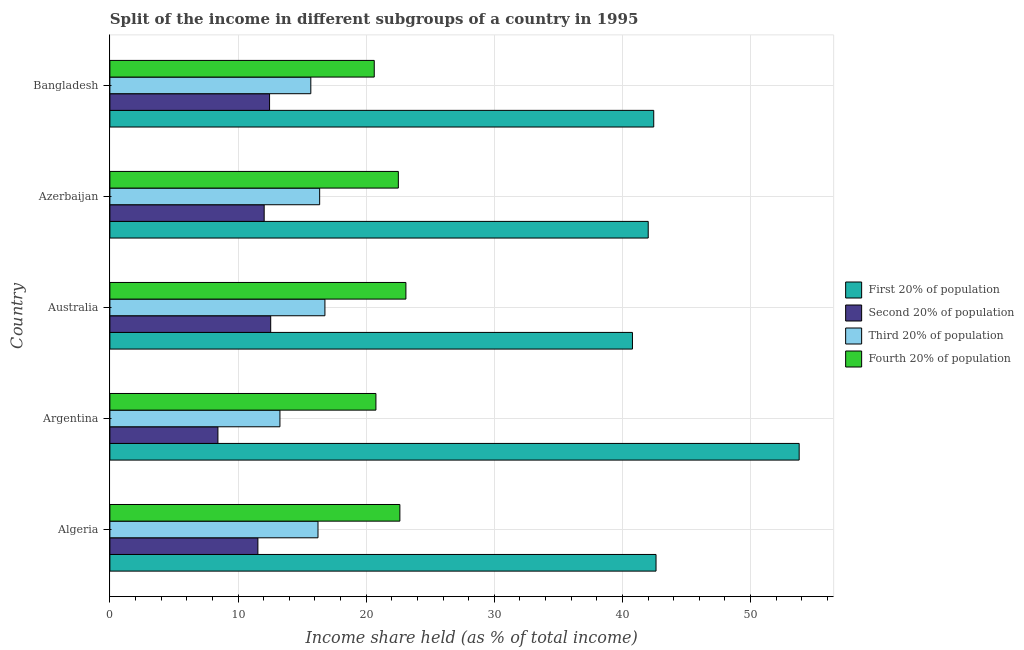Are the number of bars per tick equal to the number of legend labels?
Your answer should be very brief. Yes. How many bars are there on the 1st tick from the top?
Provide a short and direct response. 4. What is the label of the 1st group of bars from the top?
Offer a terse response. Bangladesh. In how many cases, is the number of bars for a given country not equal to the number of legend labels?
Keep it short and to the point. 0. What is the share of the income held by fourth 20% of the population in Algeria?
Offer a terse response. 22.63. Across all countries, what is the maximum share of the income held by second 20% of the population?
Your answer should be compact. 12.55. Across all countries, what is the minimum share of the income held by second 20% of the population?
Make the answer very short. 8.43. What is the total share of the income held by third 20% of the population in the graph?
Make the answer very short. 78.34. What is the difference between the share of the income held by first 20% of the population in Bangladesh and the share of the income held by second 20% of the population in Azerbaijan?
Offer a terse response. 30.4. What is the average share of the income held by third 20% of the population per country?
Provide a succinct answer. 15.67. What is the difference between the share of the income held by second 20% of the population and share of the income held by fourth 20% of the population in Australia?
Your answer should be compact. -10.55. In how many countries, is the share of the income held by third 20% of the population greater than 6 %?
Keep it short and to the point. 5. What is the difference between the highest and the second highest share of the income held by third 20% of the population?
Your answer should be compact. 0.41. What is the difference between the highest and the lowest share of the income held by second 20% of the population?
Give a very brief answer. 4.12. In how many countries, is the share of the income held by fourth 20% of the population greater than the average share of the income held by fourth 20% of the population taken over all countries?
Provide a short and direct response. 3. Is it the case that in every country, the sum of the share of the income held by second 20% of the population and share of the income held by first 20% of the population is greater than the sum of share of the income held by fourth 20% of the population and share of the income held by third 20% of the population?
Offer a terse response. Yes. What does the 3rd bar from the top in Australia represents?
Provide a succinct answer. Second 20% of population. What does the 2nd bar from the bottom in Bangladesh represents?
Offer a very short reply. Second 20% of population. Is it the case that in every country, the sum of the share of the income held by first 20% of the population and share of the income held by second 20% of the population is greater than the share of the income held by third 20% of the population?
Your response must be concise. Yes. How many countries are there in the graph?
Provide a short and direct response. 5. Does the graph contain any zero values?
Provide a short and direct response. No. How are the legend labels stacked?
Provide a succinct answer. Vertical. What is the title of the graph?
Offer a very short reply. Split of the income in different subgroups of a country in 1995. Does "Agriculture" appear as one of the legend labels in the graph?
Your response must be concise. No. What is the label or title of the X-axis?
Make the answer very short. Income share held (as % of total income). What is the label or title of the Y-axis?
Provide a succinct answer. Country. What is the Income share held (as % of total income) in First 20% of population in Algeria?
Keep it short and to the point. 42.62. What is the Income share held (as % of total income) in Second 20% of population in Algeria?
Offer a terse response. 11.55. What is the Income share held (as % of total income) in Third 20% of population in Algeria?
Your answer should be compact. 16.24. What is the Income share held (as % of total income) of Fourth 20% of population in Algeria?
Provide a succinct answer. 22.63. What is the Income share held (as % of total income) of First 20% of population in Argentina?
Provide a short and direct response. 53.79. What is the Income share held (as % of total income) of Second 20% of population in Argentina?
Make the answer very short. 8.43. What is the Income share held (as % of total income) of Third 20% of population in Argentina?
Your response must be concise. 13.27. What is the Income share held (as % of total income) of Fourth 20% of population in Argentina?
Keep it short and to the point. 20.76. What is the Income share held (as % of total income) in First 20% of population in Australia?
Your response must be concise. 40.78. What is the Income share held (as % of total income) in Second 20% of population in Australia?
Your answer should be very brief. 12.55. What is the Income share held (as % of total income) in Third 20% of population in Australia?
Offer a very short reply. 16.78. What is the Income share held (as % of total income) in Fourth 20% of population in Australia?
Your answer should be compact. 23.1. What is the Income share held (as % of total income) of First 20% of population in Azerbaijan?
Offer a terse response. 42.01. What is the Income share held (as % of total income) of Second 20% of population in Azerbaijan?
Your answer should be compact. 12.04. What is the Income share held (as % of total income) of Third 20% of population in Azerbaijan?
Your response must be concise. 16.37. What is the Income share held (as % of total income) of Fourth 20% of population in Azerbaijan?
Your answer should be compact. 22.51. What is the Income share held (as % of total income) of First 20% of population in Bangladesh?
Your answer should be compact. 42.44. What is the Income share held (as % of total income) in Second 20% of population in Bangladesh?
Ensure brevity in your answer.  12.46. What is the Income share held (as % of total income) of Third 20% of population in Bangladesh?
Ensure brevity in your answer.  15.68. What is the Income share held (as % of total income) in Fourth 20% of population in Bangladesh?
Offer a terse response. 20.63. Across all countries, what is the maximum Income share held (as % of total income) in First 20% of population?
Your answer should be very brief. 53.79. Across all countries, what is the maximum Income share held (as % of total income) in Second 20% of population?
Keep it short and to the point. 12.55. Across all countries, what is the maximum Income share held (as % of total income) in Third 20% of population?
Your response must be concise. 16.78. Across all countries, what is the maximum Income share held (as % of total income) in Fourth 20% of population?
Make the answer very short. 23.1. Across all countries, what is the minimum Income share held (as % of total income) of First 20% of population?
Provide a short and direct response. 40.78. Across all countries, what is the minimum Income share held (as % of total income) in Second 20% of population?
Your response must be concise. 8.43. Across all countries, what is the minimum Income share held (as % of total income) of Third 20% of population?
Offer a terse response. 13.27. Across all countries, what is the minimum Income share held (as % of total income) in Fourth 20% of population?
Offer a terse response. 20.63. What is the total Income share held (as % of total income) in First 20% of population in the graph?
Your answer should be compact. 221.64. What is the total Income share held (as % of total income) in Second 20% of population in the graph?
Provide a short and direct response. 57.03. What is the total Income share held (as % of total income) of Third 20% of population in the graph?
Ensure brevity in your answer.  78.34. What is the total Income share held (as % of total income) in Fourth 20% of population in the graph?
Offer a terse response. 109.63. What is the difference between the Income share held (as % of total income) of First 20% of population in Algeria and that in Argentina?
Your response must be concise. -11.17. What is the difference between the Income share held (as % of total income) of Second 20% of population in Algeria and that in Argentina?
Offer a terse response. 3.12. What is the difference between the Income share held (as % of total income) of Third 20% of population in Algeria and that in Argentina?
Give a very brief answer. 2.97. What is the difference between the Income share held (as % of total income) in Fourth 20% of population in Algeria and that in Argentina?
Provide a short and direct response. 1.87. What is the difference between the Income share held (as % of total income) in First 20% of population in Algeria and that in Australia?
Ensure brevity in your answer.  1.84. What is the difference between the Income share held (as % of total income) in Third 20% of population in Algeria and that in Australia?
Offer a very short reply. -0.54. What is the difference between the Income share held (as % of total income) of Fourth 20% of population in Algeria and that in Australia?
Provide a succinct answer. -0.47. What is the difference between the Income share held (as % of total income) of First 20% of population in Algeria and that in Azerbaijan?
Offer a very short reply. 0.61. What is the difference between the Income share held (as % of total income) in Second 20% of population in Algeria and that in Azerbaijan?
Provide a succinct answer. -0.49. What is the difference between the Income share held (as % of total income) of Third 20% of population in Algeria and that in Azerbaijan?
Give a very brief answer. -0.13. What is the difference between the Income share held (as % of total income) in Fourth 20% of population in Algeria and that in Azerbaijan?
Your answer should be very brief. 0.12. What is the difference between the Income share held (as % of total income) of First 20% of population in Algeria and that in Bangladesh?
Your answer should be very brief. 0.18. What is the difference between the Income share held (as % of total income) of Second 20% of population in Algeria and that in Bangladesh?
Your answer should be very brief. -0.91. What is the difference between the Income share held (as % of total income) of Third 20% of population in Algeria and that in Bangladesh?
Offer a terse response. 0.56. What is the difference between the Income share held (as % of total income) of Fourth 20% of population in Algeria and that in Bangladesh?
Ensure brevity in your answer.  2. What is the difference between the Income share held (as % of total income) in First 20% of population in Argentina and that in Australia?
Give a very brief answer. 13.01. What is the difference between the Income share held (as % of total income) in Second 20% of population in Argentina and that in Australia?
Offer a terse response. -4.12. What is the difference between the Income share held (as % of total income) in Third 20% of population in Argentina and that in Australia?
Your answer should be very brief. -3.51. What is the difference between the Income share held (as % of total income) of Fourth 20% of population in Argentina and that in Australia?
Offer a terse response. -2.34. What is the difference between the Income share held (as % of total income) of First 20% of population in Argentina and that in Azerbaijan?
Offer a terse response. 11.78. What is the difference between the Income share held (as % of total income) in Second 20% of population in Argentina and that in Azerbaijan?
Your answer should be compact. -3.61. What is the difference between the Income share held (as % of total income) in Third 20% of population in Argentina and that in Azerbaijan?
Ensure brevity in your answer.  -3.1. What is the difference between the Income share held (as % of total income) of Fourth 20% of population in Argentina and that in Azerbaijan?
Offer a very short reply. -1.75. What is the difference between the Income share held (as % of total income) of First 20% of population in Argentina and that in Bangladesh?
Make the answer very short. 11.35. What is the difference between the Income share held (as % of total income) of Second 20% of population in Argentina and that in Bangladesh?
Your answer should be very brief. -4.03. What is the difference between the Income share held (as % of total income) in Third 20% of population in Argentina and that in Bangladesh?
Provide a succinct answer. -2.41. What is the difference between the Income share held (as % of total income) of Fourth 20% of population in Argentina and that in Bangladesh?
Ensure brevity in your answer.  0.13. What is the difference between the Income share held (as % of total income) of First 20% of population in Australia and that in Azerbaijan?
Your response must be concise. -1.23. What is the difference between the Income share held (as % of total income) of Second 20% of population in Australia and that in Azerbaijan?
Offer a very short reply. 0.51. What is the difference between the Income share held (as % of total income) of Third 20% of population in Australia and that in Azerbaijan?
Your answer should be compact. 0.41. What is the difference between the Income share held (as % of total income) in Fourth 20% of population in Australia and that in Azerbaijan?
Provide a succinct answer. 0.59. What is the difference between the Income share held (as % of total income) of First 20% of population in Australia and that in Bangladesh?
Your response must be concise. -1.66. What is the difference between the Income share held (as % of total income) of Second 20% of population in Australia and that in Bangladesh?
Provide a succinct answer. 0.09. What is the difference between the Income share held (as % of total income) in Fourth 20% of population in Australia and that in Bangladesh?
Offer a terse response. 2.47. What is the difference between the Income share held (as % of total income) in First 20% of population in Azerbaijan and that in Bangladesh?
Give a very brief answer. -0.43. What is the difference between the Income share held (as % of total income) of Second 20% of population in Azerbaijan and that in Bangladesh?
Offer a very short reply. -0.42. What is the difference between the Income share held (as % of total income) of Third 20% of population in Azerbaijan and that in Bangladesh?
Make the answer very short. 0.69. What is the difference between the Income share held (as % of total income) of Fourth 20% of population in Azerbaijan and that in Bangladesh?
Ensure brevity in your answer.  1.88. What is the difference between the Income share held (as % of total income) in First 20% of population in Algeria and the Income share held (as % of total income) in Second 20% of population in Argentina?
Provide a short and direct response. 34.19. What is the difference between the Income share held (as % of total income) of First 20% of population in Algeria and the Income share held (as % of total income) of Third 20% of population in Argentina?
Keep it short and to the point. 29.35. What is the difference between the Income share held (as % of total income) in First 20% of population in Algeria and the Income share held (as % of total income) in Fourth 20% of population in Argentina?
Your response must be concise. 21.86. What is the difference between the Income share held (as % of total income) of Second 20% of population in Algeria and the Income share held (as % of total income) of Third 20% of population in Argentina?
Your answer should be very brief. -1.72. What is the difference between the Income share held (as % of total income) of Second 20% of population in Algeria and the Income share held (as % of total income) of Fourth 20% of population in Argentina?
Ensure brevity in your answer.  -9.21. What is the difference between the Income share held (as % of total income) of Third 20% of population in Algeria and the Income share held (as % of total income) of Fourth 20% of population in Argentina?
Your response must be concise. -4.52. What is the difference between the Income share held (as % of total income) in First 20% of population in Algeria and the Income share held (as % of total income) in Second 20% of population in Australia?
Provide a short and direct response. 30.07. What is the difference between the Income share held (as % of total income) in First 20% of population in Algeria and the Income share held (as % of total income) in Third 20% of population in Australia?
Your response must be concise. 25.84. What is the difference between the Income share held (as % of total income) of First 20% of population in Algeria and the Income share held (as % of total income) of Fourth 20% of population in Australia?
Give a very brief answer. 19.52. What is the difference between the Income share held (as % of total income) of Second 20% of population in Algeria and the Income share held (as % of total income) of Third 20% of population in Australia?
Ensure brevity in your answer.  -5.23. What is the difference between the Income share held (as % of total income) of Second 20% of population in Algeria and the Income share held (as % of total income) of Fourth 20% of population in Australia?
Give a very brief answer. -11.55. What is the difference between the Income share held (as % of total income) in Third 20% of population in Algeria and the Income share held (as % of total income) in Fourth 20% of population in Australia?
Provide a short and direct response. -6.86. What is the difference between the Income share held (as % of total income) in First 20% of population in Algeria and the Income share held (as % of total income) in Second 20% of population in Azerbaijan?
Give a very brief answer. 30.58. What is the difference between the Income share held (as % of total income) of First 20% of population in Algeria and the Income share held (as % of total income) of Third 20% of population in Azerbaijan?
Ensure brevity in your answer.  26.25. What is the difference between the Income share held (as % of total income) of First 20% of population in Algeria and the Income share held (as % of total income) of Fourth 20% of population in Azerbaijan?
Your answer should be very brief. 20.11. What is the difference between the Income share held (as % of total income) of Second 20% of population in Algeria and the Income share held (as % of total income) of Third 20% of population in Azerbaijan?
Offer a very short reply. -4.82. What is the difference between the Income share held (as % of total income) of Second 20% of population in Algeria and the Income share held (as % of total income) of Fourth 20% of population in Azerbaijan?
Keep it short and to the point. -10.96. What is the difference between the Income share held (as % of total income) of Third 20% of population in Algeria and the Income share held (as % of total income) of Fourth 20% of population in Azerbaijan?
Ensure brevity in your answer.  -6.27. What is the difference between the Income share held (as % of total income) of First 20% of population in Algeria and the Income share held (as % of total income) of Second 20% of population in Bangladesh?
Your response must be concise. 30.16. What is the difference between the Income share held (as % of total income) in First 20% of population in Algeria and the Income share held (as % of total income) in Third 20% of population in Bangladesh?
Give a very brief answer. 26.94. What is the difference between the Income share held (as % of total income) of First 20% of population in Algeria and the Income share held (as % of total income) of Fourth 20% of population in Bangladesh?
Give a very brief answer. 21.99. What is the difference between the Income share held (as % of total income) in Second 20% of population in Algeria and the Income share held (as % of total income) in Third 20% of population in Bangladesh?
Your response must be concise. -4.13. What is the difference between the Income share held (as % of total income) of Second 20% of population in Algeria and the Income share held (as % of total income) of Fourth 20% of population in Bangladesh?
Your response must be concise. -9.08. What is the difference between the Income share held (as % of total income) in Third 20% of population in Algeria and the Income share held (as % of total income) in Fourth 20% of population in Bangladesh?
Offer a terse response. -4.39. What is the difference between the Income share held (as % of total income) in First 20% of population in Argentina and the Income share held (as % of total income) in Second 20% of population in Australia?
Your response must be concise. 41.24. What is the difference between the Income share held (as % of total income) of First 20% of population in Argentina and the Income share held (as % of total income) of Third 20% of population in Australia?
Offer a very short reply. 37.01. What is the difference between the Income share held (as % of total income) in First 20% of population in Argentina and the Income share held (as % of total income) in Fourth 20% of population in Australia?
Keep it short and to the point. 30.69. What is the difference between the Income share held (as % of total income) of Second 20% of population in Argentina and the Income share held (as % of total income) of Third 20% of population in Australia?
Provide a succinct answer. -8.35. What is the difference between the Income share held (as % of total income) in Second 20% of population in Argentina and the Income share held (as % of total income) in Fourth 20% of population in Australia?
Offer a terse response. -14.67. What is the difference between the Income share held (as % of total income) of Third 20% of population in Argentina and the Income share held (as % of total income) of Fourth 20% of population in Australia?
Provide a succinct answer. -9.83. What is the difference between the Income share held (as % of total income) of First 20% of population in Argentina and the Income share held (as % of total income) of Second 20% of population in Azerbaijan?
Provide a short and direct response. 41.75. What is the difference between the Income share held (as % of total income) of First 20% of population in Argentina and the Income share held (as % of total income) of Third 20% of population in Azerbaijan?
Offer a very short reply. 37.42. What is the difference between the Income share held (as % of total income) of First 20% of population in Argentina and the Income share held (as % of total income) of Fourth 20% of population in Azerbaijan?
Your answer should be compact. 31.28. What is the difference between the Income share held (as % of total income) in Second 20% of population in Argentina and the Income share held (as % of total income) in Third 20% of population in Azerbaijan?
Your answer should be compact. -7.94. What is the difference between the Income share held (as % of total income) in Second 20% of population in Argentina and the Income share held (as % of total income) in Fourth 20% of population in Azerbaijan?
Provide a short and direct response. -14.08. What is the difference between the Income share held (as % of total income) of Third 20% of population in Argentina and the Income share held (as % of total income) of Fourth 20% of population in Azerbaijan?
Give a very brief answer. -9.24. What is the difference between the Income share held (as % of total income) in First 20% of population in Argentina and the Income share held (as % of total income) in Second 20% of population in Bangladesh?
Ensure brevity in your answer.  41.33. What is the difference between the Income share held (as % of total income) in First 20% of population in Argentina and the Income share held (as % of total income) in Third 20% of population in Bangladesh?
Your answer should be very brief. 38.11. What is the difference between the Income share held (as % of total income) of First 20% of population in Argentina and the Income share held (as % of total income) of Fourth 20% of population in Bangladesh?
Offer a very short reply. 33.16. What is the difference between the Income share held (as % of total income) of Second 20% of population in Argentina and the Income share held (as % of total income) of Third 20% of population in Bangladesh?
Provide a succinct answer. -7.25. What is the difference between the Income share held (as % of total income) in Second 20% of population in Argentina and the Income share held (as % of total income) in Fourth 20% of population in Bangladesh?
Your answer should be compact. -12.2. What is the difference between the Income share held (as % of total income) in Third 20% of population in Argentina and the Income share held (as % of total income) in Fourth 20% of population in Bangladesh?
Give a very brief answer. -7.36. What is the difference between the Income share held (as % of total income) in First 20% of population in Australia and the Income share held (as % of total income) in Second 20% of population in Azerbaijan?
Offer a terse response. 28.74. What is the difference between the Income share held (as % of total income) of First 20% of population in Australia and the Income share held (as % of total income) of Third 20% of population in Azerbaijan?
Give a very brief answer. 24.41. What is the difference between the Income share held (as % of total income) of First 20% of population in Australia and the Income share held (as % of total income) of Fourth 20% of population in Azerbaijan?
Your response must be concise. 18.27. What is the difference between the Income share held (as % of total income) of Second 20% of population in Australia and the Income share held (as % of total income) of Third 20% of population in Azerbaijan?
Make the answer very short. -3.82. What is the difference between the Income share held (as % of total income) of Second 20% of population in Australia and the Income share held (as % of total income) of Fourth 20% of population in Azerbaijan?
Your response must be concise. -9.96. What is the difference between the Income share held (as % of total income) in Third 20% of population in Australia and the Income share held (as % of total income) in Fourth 20% of population in Azerbaijan?
Your answer should be compact. -5.73. What is the difference between the Income share held (as % of total income) of First 20% of population in Australia and the Income share held (as % of total income) of Second 20% of population in Bangladesh?
Keep it short and to the point. 28.32. What is the difference between the Income share held (as % of total income) in First 20% of population in Australia and the Income share held (as % of total income) in Third 20% of population in Bangladesh?
Give a very brief answer. 25.1. What is the difference between the Income share held (as % of total income) in First 20% of population in Australia and the Income share held (as % of total income) in Fourth 20% of population in Bangladesh?
Your response must be concise. 20.15. What is the difference between the Income share held (as % of total income) of Second 20% of population in Australia and the Income share held (as % of total income) of Third 20% of population in Bangladesh?
Ensure brevity in your answer.  -3.13. What is the difference between the Income share held (as % of total income) of Second 20% of population in Australia and the Income share held (as % of total income) of Fourth 20% of population in Bangladesh?
Offer a very short reply. -8.08. What is the difference between the Income share held (as % of total income) in Third 20% of population in Australia and the Income share held (as % of total income) in Fourth 20% of population in Bangladesh?
Provide a short and direct response. -3.85. What is the difference between the Income share held (as % of total income) in First 20% of population in Azerbaijan and the Income share held (as % of total income) in Second 20% of population in Bangladesh?
Provide a short and direct response. 29.55. What is the difference between the Income share held (as % of total income) of First 20% of population in Azerbaijan and the Income share held (as % of total income) of Third 20% of population in Bangladesh?
Provide a succinct answer. 26.33. What is the difference between the Income share held (as % of total income) in First 20% of population in Azerbaijan and the Income share held (as % of total income) in Fourth 20% of population in Bangladesh?
Keep it short and to the point. 21.38. What is the difference between the Income share held (as % of total income) in Second 20% of population in Azerbaijan and the Income share held (as % of total income) in Third 20% of population in Bangladesh?
Provide a short and direct response. -3.64. What is the difference between the Income share held (as % of total income) of Second 20% of population in Azerbaijan and the Income share held (as % of total income) of Fourth 20% of population in Bangladesh?
Your answer should be compact. -8.59. What is the difference between the Income share held (as % of total income) in Third 20% of population in Azerbaijan and the Income share held (as % of total income) in Fourth 20% of population in Bangladesh?
Your answer should be compact. -4.26. What is the average Income share held (as % of total income) in First 20% of population per country?
Your response must be concise. 44.33. What is the average Income share held (as % of total income) in Second 20% of population per country?
Your response must be concise. 11.41. What is the average Income share held (as % of total income) of Third 20% of population per country?
Your response must be concise. 15.67. What is the average Income share held (as % of total income) of Fourth 20% of population per country?
Give a very brief answer. 21.93. What is the difference between the Income share held (as % of total income) of First 20% of population and Income share held (as % of total income) of Second 20% of population in Algeria?
Keep it short and to the point. 31.07. What is the difference between the Income share held (as % of total income) in First 20% of population and Income share held (as % of total income) in Third 20% of population in Algeria?
Make the answer very short. 26.38. What is the difference between the Income share held (as % of total income) of First 20% of population and Income share held (as % of total income) of Fourth 20% of population in Algeria?
Your response must be concise. 19.99. What is the difference between the Income share held (as % of total income) in Second 20% of population and Income share held (as % of total income) in Third 20% of population in Algeria?
Provide a succinct answer. -4.69. What is the difference between the Income share held (as % of total income) of Second 20% of population and Income share held (as % of total income) of Fourth 20% of population in Algeria?
Provide a succinct answer. -11.08. What is the difference between the Income share held (as % of total income) in Third 20% of population and Income share held (as % of total income) in Fourth 20% of population in Algeria?
Your response must be concise. -6.39. What is the difference between the Income share held (as % of total income) of First 20% of population and Income share held (as % of total income) of Second 20% of population in Argentina?
Keep it short and to the point. 45.36. What is the difference between the Income share held (as % of total income) of First 20% of population and Income share held (as % of total income) of Third 20% of population in Argentina?
Provide a short and direct response. 40.52. What is the difference between the Income share held (as % of total income) in First 20% of population and Income share held (as % of total income) in Fourth 20% of population in Argentina?
Your answer should be very brief. 33.03. What is the difference between the Income share held (as % of total income) in Second 20% of population and Income share held (as % of total income) in Third 20% of population in Argentina?
Provide a short and direct response. -4.84. What is the difference between the Income share held (as % of total income) of Second 20% of population and Income share held (as % of total income) of Fourth 20% of population in Argentina?
Your response must be concise. -12.33. What is the difference between the Income share held (as % of total income) of Third 20% of population and Income share held (as % of total income) of Fourth 20% of population in Argentina?
Your answer should be compact. -7.49. What is the difference between the Income share held (as % of total income) of First 20% of population and Income share held (as % of total income) of Second 20% of population in Australia?
Offer a terse response. 28.23. What is the difference between the Income share held (as % of total income) in First 20% of population and Income share held (as % of total income) in Fourth 20% of population in Australia?
Provide a succinct answer. 17.68. What is the difference between the Income share held (as % of total income) in Second 20% of population and Income share held (as % of total income) in Third 20% of population in Australia?
Give a very brief answer. -4.23. What is the difference between the Income share held (as % of total income) in Second 20% of population and Income share held (as % of total income) in Fourth 20% of population in Australia?
Make the answer very short. -10.55. What is the difference between the Income share held (as % of total income) of Third 20% of population and Income share held (as % of total income) of Fourth 20% of population in Australia?
Offer a very short reply. -6.32. What is the difference between the Income share held (as % of total income) of First 20% of population and Income share held (as % of total income) of Second 20% of population in Azerbaijan?
Your answer should be compact. 29.97. What is the difference between the Income share held (as % of total income) of First 20% of population and Income share held (as % of total income) of Third 20% of population in Azerbaijan?
Give a very brief answer. 25.64. What is the difference between the Income share held (as % of total income) in Second 20% of population and Income share held (as % of total income) in Third 20% of population in Azerbaijan?
Offer a terse response. -4.33. What is the difference between the Income share held (as % of total income) of Second 20% of population and Income share held (as % of total income) of Fourth 20% of population in Azerbaijan?
Ensure brevity in your answer.  -10.47. What is the difference between the Income share held (as % of total income) of Third 20% of population and Income share held (as % of total income) of Fourth 20% of population in Azerbaijan?
Offer a very short reply. -6.14. What is the difference between the Income share held (as % of total income) in First 20% of population and Income share held (as % of total income) in Second 20% of population in Bangladesh?
Provide a short and direct response. 29.98. What is the difference between the Income share held (as % of total income) of First 20% of population and Income share held (as % of total income) of Third 20% of population in Bangladesh?
Your answer should be very brief. 26.76. What is the difference between the Income share held (as % of total income) in First 20% of population and Income share held (as % of total income) in Fourth 20% of population in Bangladesh?
Give a very brief answer. 21.81. What is the difference between the Income share held (as % of total income) of Second 20% of population and Income share held (as % of total income) of Third 20% of population in Bangladesh?
Provide a succinct answer. -3.22. What is the difference between the Income share held (as % of total income) in Second 20% of population and Income share held (as % of total income) in Fourth 20% of population in Bangladesh?
Provide a short and direct response. -8.17. What is the difference between the Income share held (as % of total income) of Third 20% of population and Income share held (as % of total income) of Fourth 20% of population in Bangladesh?
Offer a terse response. -4.95. What is the ratio of the Income share held (as % of total income) of First 20% of population in Algeria to that in Argentina?
Ensure brevity in your answer.  0.79. What is the ratio of the Income share held (as % of total income) of Second 20% of population in Algeria to that in Argentina?
Offer a very short reply. 1.37. What is the ratio of the Income share held (as % of total income) of Third 20% of population in Algeria to that in Argentina?
Provide a succinct answer. 1.22. What is the ratio of the Income share held (as % of total income) of Fourth 20% of population in Algeria to that in Argentina?
Your answer should be compact. 1.09. What is the ratio of the Income share held (as % of total income) of First 20% of population in Algeria to that in Australia?
Ensure brevity in your answer.  1.05. What is the ratio of the Income share held (as % of total income) in Second 20% of population in Algeria to that in Australia?
Give a very brief answer. 0.92. What is the ratio of the Income share held (as % of total income) of Third 20% of population in Algeria to that in Australia?
Your answer should be compact. 0.97. What is the ratio of the Income share held (as % of total income) of Fourth 20% of population in Algeria to that in Australia?
Offer a terse response. 0.98. What is the ratio of the Income share held (as % of total income) in First 20% of population in Algeria to that in Azerbaijan?
Provide a short and direct response. 1.01. What is the ratio of the Income share held (as % of total income) of Second 20% of population in Algeria to that in Azerbaijan?
Your answer should be very brief. 0.96. What is the ratio of the Income share held (as % of total income) of Third 20% of population in Algeria to that in Azerbaijan?
Your response must be concise. 0.99. What is the ratio of the Income share held (as % of total income) in First 20% of population in Algeria to that in Bangladesh?
Your answer should be compact. 1. What is the ratio of the Income share held (as % of total income) in Second 20% of population in Algeria to that in Bangladesh?
Offer a very short reply. 0.93. What is the ratio of the Income share held (as % of total income) in Third 20% of population in Algeria to that in Bangladesh?
Keep it short and to the point. 1.04. What is the ratio of the Income share held (as % of total income) in Fourth 20% of population in Algeria to that in Bangladesh?
Keep it short and to the point. 1.1. What is the ratio of the Income share held (as % of total income) in First 20% of population in Argentina to that in Australia?
Make the answer very short. 1.32. What is the ratio of the Income share held (as % of total income) in Second 20% of population in Argentina to that in Australia?
Keep it short and to the point. 0.67. What is the ratio of the Income share held (as % of total income) in Third 20% of population in Argentina to that in Australia?
Your response must be concise. 0.79. What is the ratio of the Income share held (as % of total income) in Fourth 20% of population in Argentina to that in Australia?
Provide a succinct answer. 0.9. What is the ratio of the Income share held (as % of total income) in First 20% of population in Argentina to that in Azerbaijan?
Offer a very short reply. 1.28. What is the ratio of the Income share held (as % of total income) in Second 20% of population in Argentina to that in Azerbaijan?
Your answer should be compact. 0.7. What is the ratio of the Income share held (as % of total income) of Third 20% of population in Argentina to that in Azerbaijan?
Provide a succinct answer. 0.81. What is the ratio of the Income share held (as % of total income) in Fourth 20% of population in Argentina to that in Azerbaijan?
Provide a succinct answer. 0.92. What is the ratio of the Income share held (as % of total income) of First 20% of population in Argentina to that in Bangladesh?
Your answer should be compact. 1.27. What is the ratio of the Income share held (as % of total income) in Second 20% of population in Argentina to that in Bangladesh?
Make the answer very short. 0.68. What is the ratio of the Income share held (as % of total income) of Third 20% of population in Argentina to that in Bangladesh?
Provide a short and direct response. 0.85. What is the ratio of the Income share held (as % of total income) in First 20% of population in Australia to that in Azerbaijan?
Provide a short and direct response. 0.97. What is the ratio of the Income share held (as % of total income) in Second 20% of population in Australia to that in Azerbaijan?
Give a very brief answer. 1.04. What is the ratio of the Income share held (as % of total income) of Third 20% of population in Australia to that in Azerbaijan?
Your response must be concise. 1.02. What is the ratio of the Income share held (as % of total income) in Fourth 20% of population in Australia to that in Azerbaijan?
Your answer should be compact. 1.03. What is the ratio of the Income share held (as % of total income) of First 20% of population in Australia to that in Bangladesh?
Your answer should be very brief. 0.96. What is the ratio of the Income share held (as % of total income) of Third 20% of population in Australia to that in Bangladesh?
Offer a very short reply. 1.07. What is the ratio of the Income share held (as % of total income) in Fourth 20% of population in Australia to that in Bangladesh?
Make the answer very short. 1.12. What is the ratio of the Income share held (as % of total income) of Second 20% of population in Azerbaijan to that in Bangladesh?
Give a very brief answer. 0.97. What is the ratio of the Income share held (as % of total income) in Third 20% of population in Azerbaijan to that in Bangladesh?
Your answer should be very brief. 1.04. What is the ratio of the Income share held (as % of total income) in Fourth 20% of population in Azerbaijan to that in Bangladesh?
Your response must be concise. 1.09. What is the difference between the highest and the second highest Income share held (as % of total income) in First 20% of population?
Provide a short and direct response. 11.17. What is the difference between the highest and the second highest Income share held (as % of total income) of Second 20% of population?
Your response must be concise. 0.09. What is the difference between the highest and the second highest Income share held (as % of total income) in Third 20% of population?
Make the answer very short. 0.41. What is the difference between the highest and the second highest Income share held (as % of total income) of Fourth 20% of population?
Your answer should be compact. 0.47. What is the difference between the highest and the lowest Income share held (as % of total income) of First 20% of population?
Provide a short and direct response. 13.01. What is the difference between the highest and the lowest Income share held (as % of total income) in Second 20% of population?
Keep it short and to the point. 4.12. What is the difference between the highest and the lowest Income share held (as % of total income) of Third 20% of population?
Your answer should be very brief. 3.51. What is the difference between the highest and the lowest Income share held (as % of total income) of Fourth 20% of population?
Keep it short and to the point. 2.47. 